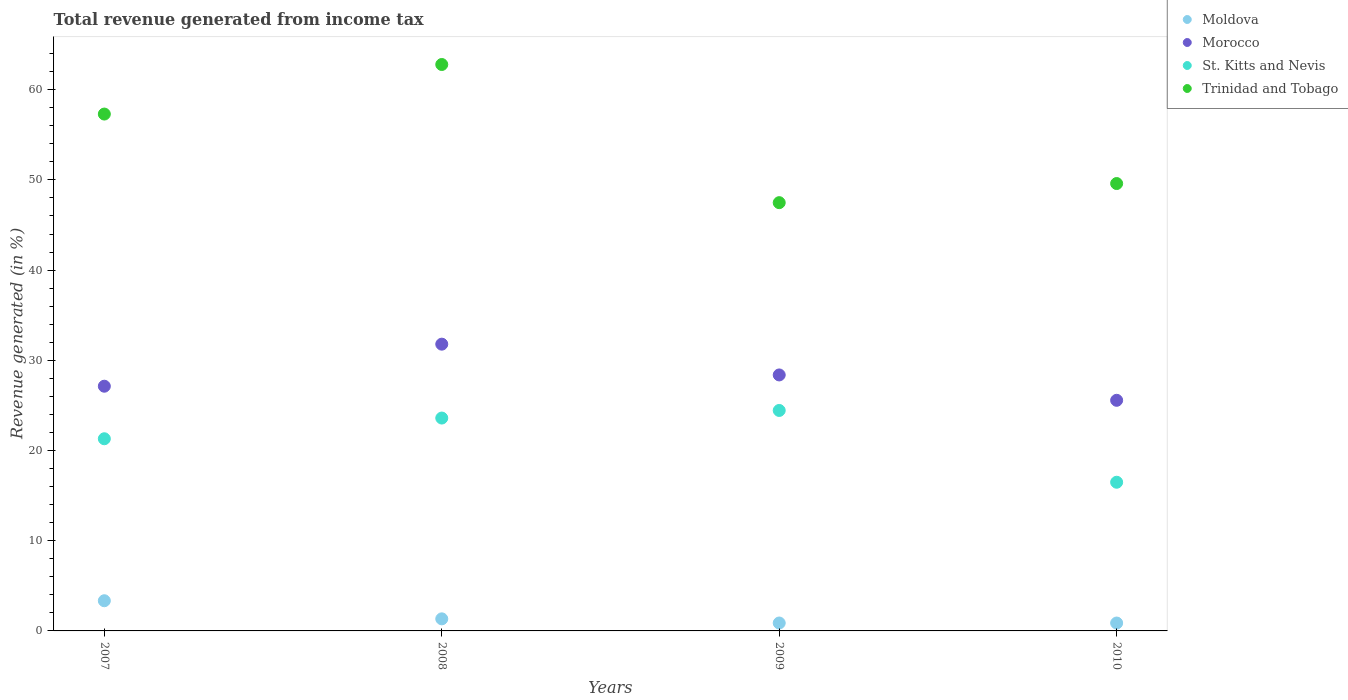How many different coloured dotlines are there?
Keep it short and to the point. 4. Is the number of dotlines equal to the number of legend labels?
Give a very brief answer. Yes. What is the total revenue generated in Moldova in 2007?
Provide a succinct answer. 3.35. Across all years, what is the maximum total revenue generated in St. Kitts and Nevis?
Offer a very short reply. 24.44. Across all years, what is the minimum total revenue generated in St. Kitts and Nevis?
Provide a succinct answer. 16.48. In which year was the total revenue generated in St. Kitts and Nevis minimum?
Your answer should be compact. 2010. What is the total total revenue generated in St. Kitts and Nevis in the graph?
Your answer should be very brief. 85.83. What is the difference between the total revenue generated in St. Kitts and Nevis in 2007 and that in 2008?
Ensure brevity in your answer.  -2.3. What is the difference between the total revenue generated in Trinidad and Tobago in 2009 and the total revenue generated in Moldova in 2008?
Give a very brief answer. 46.14. What is the average total revenue generated in St. Kitts and Nevis per year?
Provide a succinct answer. 21.46. In the year 2010, what is the difference between the total revenue generated in Trinidad and Tobago and total revenue generated in Morocco?
Your response must be concise. 24.03. In how many years, is the total revenue generated in Moldova greater than 32 %?
Ensure brevity in your answer.  0. What is the ratio of the total revenue generated in Moldova in 2007 to that in 2010?
Provide a short and direct response. 3.83. What is the difference between the highest and the second highest total revenue generated in Morocco?
Offer a very short reply. 3.41. What is the difference between the highest and the lowest total revenue generated in Moldova?
Offer a very short reply. 2.47. In how many years, is the total revenue generated in St. Kitts and Nevis greater than the average total revenue generated in St. Kitts and Nevis taken over all years?
Provide a short and direct response. 2. Is the sum of the total revenue generated in Moldova in 2007 and 2009 greater than the maximum total revenue generated in Morocco across all years?
Give a very brief answer. No. Is it the case that in every year, the sum of the total revenue generated in Trinidad and Tobago and total revenue generated in Moldova  is greater than the sum of total revenue generated in St. Kitts and Nevis and total revenue generated in Morocco?
Ensure brevity in your answer.  No. Is it the case that in every year, the sum of the total revenue generated in Trinidad and Tobago and total revenue generated in St. Kitts and Nevis  is greater than the total revenue generated in Moldova?
Your response must be concise. Yes. Does the total revenue generated in Moldova monotonically increase over the years?
Provide a short and direct response. No. Is the total revenue generated in Trinidad and Tobago strictly greater than the total revenue generated in St. Kitts and Nevis over the years?
Ensure brevity in your answer.  Yes. How many dotlines are there?
Your answer should be compact. 4. Are the values on the major ticks of Y-axis written in scientific E-notation?
Provide a succinct answer. No. Does the graph contain any zero values?
Offer a terse response. No. Where does the legend appear in the graph?
Provide a short and direct response. Top right. How are the legend labels stacked?
Give a very brief answer. Vertical. What is the title of the graph?
Ensure brevity in your answer.  Total revenue generated from income tax. What is the label or title of the X-axis?
Keep it short and to the point. Years. What is the label or title of the Y-axis?
Provide a succinct answer. Revenue generated (in %). What is the Revenue generated (in %) of Moldova in 2007?
Your answer should be very brief. 3.35. What is the Revenue generated (in %) of Morocco in 2007?
Offer a very short reply. 27.13. What is the Revenue generated (in %) in St. Kitts and Nevis in 2007?
Keep it short and to the point. 21.3. What is the Revenue generated (in %) of Trinidad and Tobago in 2007?
Provide a succinct answer. 57.3. What is the Revenue generated (in %) of Moldova in 2008?
Your answer should be compact. 1.34. What is the Revenue generated (in %) of Morocco in 2008?
Give a very brief answer. 31.79. What is the Revenue generated (in %) in St. Kitts and Nevis in 2008?
Provide a succinct answer. 23.6. What is the Revenue generated (in %) of Trinidad and Tobago in 2008?
Provide a short and direct response. 62.79. What is the Revenue generated (in %) of Moldova in 2009?
Give a very brief answer. 0.88. What is the Revenue generated (in %) of Morocco in 2009?
Offer a very short reply. 28.38. What is the Revenue generated (in %) of St. Kitts and Nevis in 2009?
Ensure brevity in your answer.  24.44. What is the Revenue generated (in %) in Trinidad and Tobago in 2009?
Make the answer very short. 47.48. What is the Revenue generated (in %) of Moldova in 2010?
Your answer should be very brief. 0.87. What is the Revenue generated (in %) in Morocco in 2010?
Offer a very short reply. 25.57. What is the Revenue generated (in %) of St. Kitts and Nevis in 2010?
Provide a succinct answer. 16.48. What is the Revenue generated (in %) of Trinidad and Tobago in 2010?
Your answer should be very brief. 49.6. Across all years, what is the maximum Revenue generated (in %) of Moldova?
Give a very brief answer. 3.35. Across all years, what is the maximum Revenue generated (in %) of Morocco?
Ensure brevity in your answer.  31.79. Across all years, what is the maximum Revenue generated (in %) in St. Kitts and Nevis?
Ensure brevity in your answer.  24.44. Across all years, what is the maximum Revenue generated (in %) of Trinidad and Tobago?
Make the answer very short. 62.79. Across all years, what is the minimum Revenue generated (in %) in Moldova?
Your response must be concise. 0.87. Across all years, what is the minimum Revenue generated (in %) in Morocco?
Provide a short and direct response. 25.57. Across all years, what is the minimum Revenue generated (in %) in St. Kitts and Nevis?
Provide a short and direct response. 16.48. Across all years, what is the minimum Revenue generated (in %) of Trinidad and Tobago?
Provide a succinct answer. 47.48. What is the total Revenue generated (in %) of Moldova in the graph?
Your answer should be compact. 6.44. What is the total Revenue generated (in %) in Morocco in the graph?
Your response must be concise. 112.86. What is the total Revenue generated (in %) of St. Kitts and Nevis in the graph?
Your response must be concise. 85.83. What is the total Revenue generated (in %) in Trinidad and Tobago in the graph?
Your response must be concise. 217.17. What is the difference between the Revenue generated (in %) of Moldova in 2007 and that in 2008?
Keep it short and to the point. 2.01. What is the difference between the Revenue generated (in %) of Morocco in 2007 and that in 2008?
Offer a very short reply. -4.66. What is the difference between the Revenue generated (in %) of St. Kitts and Nevis in 2007 and that in 2008?
Your answer should be compact. -2.3. What is the difference between the Revenue generated (in %) of Trinidad and Tobago in 2007 and that in 2008?
Ensure brevity in your answer.  -5.49. What is the difference between the Revenue generated (in %) of Moldova in 2007 and that in 2009?
Offer a very short reply. 2.47. What is the difference between the Revenue generated (in %) of Morocco in 2007 and that in 2009?
Keep it short and to the point. -1.25. What is the difference between the Revenue generated (in %) in St. Kitts and Nevis in 2007 and that in 2009?
Offer a terse response. -3.14. What is the difference between the Revenue generated (in %) in Trinidad and Tobago in 2007 and that in 2009?
Your answer should be compact. 9.82. What is the difference between the Revenue generated (in %) in Moldova in 2007 and that in 2010?
Give a very brief answer. 2.47. What is the difference between the Revenue generated (in %) in Morocco in 2007 and that in 2010?
Keep it short and to the point. 1.56. What is the difference between the Revenue generated (in %) of St. Kitts and Nevis in 2007 and that in 2010?
Your answer should be very brief. 4.82. What is the difference between the Revenue generated (in %) of Trinidad and Tobago in 2007 and that in 2010?
Make the answer very short. 7.7. What is the difference between the Revenue generated (in %) in Moldova in 2008 and that in 2009?
Your response must be concise. 0.46. What is the difference between the Revenue generated (in %) in Morocco in 2008 and that in 2009?
Provide a succinct answer. 3.41. What is the difference between the Revenue generated (in %) of St. Kitts and Nevis in 2008 and that in 2009?
Provide a succinct answer. -0.84. What is the difference between the Revenue generated (in %) in Trinidad and Tobago in 2008 and that in 2009?
Give a very brief answer. 15.32. What is the difference between the Revenue generated (in %) in Moldova in 2008 and that in 2010?
Make the answer very short. 0.46. What is the difference between the Revenue generated (in %) in Morocco in 2008 and that in 2010?
Your answer should be very brief. 6.22. What is the difference between the Revenue generated (in %) of St. Kitts and Nevis in 2008 and that in 2010?
Your answer should be compact. 7.12. What is the difference between the Revenue generated (in %) of Trinidad and Tobago in 2008 and that in 2010?
Provide a short and direct response. 13.2. What is the difference between the Revenue generated (in %) in Moldova in 2009 and that in 2010?
Ensure brevity in your answer.  0. What is the difference between the Revenue generated (in %) of Morocco in 2009 and that in 2010?
Keep it short and to the point. 2.81. What is the difference between the Revenue generated (in %) in St. Kitts and Nevis in 2009 and that in 2010?
Provide a succinct answer. 7.96. What is the difference between the Revenue generated (in %) in Trinidad and Tobago in 2009 and that in 2010?
Give a very brief answer. -2.12. What is the difference between the Revenue generated (in %) in Moldova in 2007 and the Revenue generated (in %) in Morocco in 2008?
Give a very brief answer. -28.44. What is the difference between the Revenue generated (in %) in Moldova in 2007 and the Revenue generated (in %) in St. Kitts and Nevis in 2008?
Ensure brevity in your answer.  -20.25. What is the difference between the Revenue generated (in %) in Moldova in 2007 and the Revenue generated (in %) in Trinidad and Tobago in 2008?
Your answer should be very brief. -59.45. What is the difference between the Revenue generated (in %) in Morocco in 2007 and the Revenue generated (in %) in St. Kitts and Nevis in 2008?
Offer a terse response. 3.53. What is the difference between the Revenue generated (in %) of Morocco in 2007 and the Revenue generated (in %) of Trinidad and Tobago in 2008?
Your answer should be compact. -35.67. What is the difference between the Revenue generated (in %) of St. Kitts and Nevis in 2007 and the Revenue generated (in %) of Trinidad and Tobago in 2008?
Ensure brevity in your answer.  -41.49. What is the difference between the Revenue generated (in %) of Moldova in 2007 and the Revenue generated (in %) of Morocco in 2009?
Give a very brief answer. -25.03. What is the difference between the Revenue generated (in %) in Moldova in 2007 and the Revenue generated (in %) in St. Kitts and Nevis in 2009?
Offer a very short reply. -21.1. What is the difference between the Revenue generated (in %) in Moldova in 2007 and the Revenue generated (in %) in Trinidad and Tobago in 2009?
Ensure brevity in your answer.  -44.13. What is the difference between the Revenue generated (in %) in Morocco in 2007 and the Revenue generated (in %) in St. Kitts and Nevis in 2009?
Offer a very short reply. 2.69. What is the difference between the Revenue generated (in %) of Morocco in 2007 and the Revenue generated (in %) of Trinidad and Tobago in 2009?
Your response must be concise. -20.35. What is the difference between the Revenue generated (in %) of St. Kitts and Nevis in 2007 and the Revenue generated (in %) of Trinidad and Tobago in 2009?
Offer a terse response. -26.17. What is the difference between the Revenue generated (in %) in Moldova in 2007 and the Revenue generated (in %) in Morocco in 2010?
Your response must be concise. -22.22. What is the difference between the Revenue generated (in %) of Moldova in 2007 and the Revenue generated (in %) of St. Kitts and Nevis in 2010?
Your answer should be very brief. -13.14. What is the difference between the Revenue generated (in %) in Moldova in 2007 and the Revenue generated (in %) in Trinidad and Tobago in 2010?
Ensure brevity in your answer.  -46.25. What is the difference between the Revenue generated (in %) in Morocco in 2007 and the Revenue generated (in %) in St. Kitts and Nevis in 2010?
Keep it short and to the point. 10.65. What is the difference between the Revenue generated (in %) of Morocco in 2007 and the Revenue generated (in %) of Trinidad and Tobago in 2010?
Offer a very short reply. -22.47. What is the difference between the Revenue generated (in %) in St. Kitts and Nevis in 2007 and the Revenue generated (in %) in Trinidad and Tobago in 2010?
Offer a terse response. -28.29. What is the difference between the Revenue generated (in %) of Moldova in 2008 and the Revenue generated (in %) of Morocco in 2009?
Keep it short and to the point. -27.04. What is the difference between the Revenue generated (in %) of Moldova in 2008 and the Revenue generated (in %) of St. Kitts and Nevis in 2009?
Your answer should be compact. -23.1. What is the difference between the Revenue generated (in %) of Moldova in 2008 and the Revenue generated (in %) of Trinidad and Tobago in 2009?
Offer a very short reply. -46.14. What is the difference between the Revenue generated (in %) of Morocco in 2008 and the Revenue generated (in %) of St. Kitts and Nevis in 2009?
Your response must be concise. 7.35. What is the difference between the Revenue generated (in %) of Morocco in 2008 and the Revenue generated (in %) of Trinidad and Tobago in 2009?
Give a very brief answer. -15.69. What is the difference between the Revenue generated (in %) of St. Kitts and Nevis in 2008 and the Revenue generated (in %) of Trinidad and Tobago in 2009?
Keep it short and to the point. -23.88. What is the difference between the Revenue generated (in %) of Moldova in 2008 and the Revenue generated (in %) of Morocco in 2010?
Provide a succinct answer. -24.23. What is the difference between the Revenue generated (in %) of Moldova in 2008 and the Revenue generated (in %) of St. Kitts and Nevis in 2010?
Make the answer very short. -15.14. What is the difference between the Revenue generated (in %) in Moldova in 2008 and the Revenue generated (in %) in Trinidad and Tobago in 2010?
Your answer should be very brief. -48.26. What is the difference between the Revenue generated (in %) in Morocco in 2008 and the Revenue generated (in %) in St. Kitts and Nevis in 2010?
Give a very brief answer. 15.31. What is the difference between the Revenue generated (in %) of Morocco in 2008 and the Revenue generated (in %) of Trinidad and Tobago in 2010?
Give a very brief answer. -17.81. What is the difference between the Revenue generated (in %) in St. Kitts and Nevis in 2008 and the Revenue generated (in %) in Trinidad and Tobago in 2010?
Your response must be concise. -26. What is the difference between the Revenue generated (in %) in Moldova in 2009 and the Revenue generated (in %) in Morocco in 2010?
Give a very brief answer. -24.69. What is the difference between the Revenue generated (in %) in Moldova in 2009 and the Revenue generated (in %) in St. Kitts and Nevis in 2010?
Ensure brevity in your answer.  -15.61. What is the difference between the Revenue generated (in %) in Moldova in 2009 and the Revenue generated (in %) in Trinidad and Tobago in 2010?
Give a very brief answer. -48.72. What is the difference between the Revenue generated (in %) of Morocco in 2009 and the Revenue generated (in %) of St. Kitts and Nevis in 2010?
Provide a succinct answer. 11.9. What is the difference between the Revenue generated (in %) in Morocco in 2009 and the Revenue generated (in %) in Trinidad and Tobago in 2010?
Your response must be concise. -21.22. What is the difference between the Revenue generated (in %) of St. Kitts and Nevis in 2009 and the Revenue generated (in %) of Trinidad and Tobago in 2010?
Give a very brief answer. -25.16. What is the average Revenue generated (in %) of Moldova per year?
Make the answer very short. 1.61. What is the average Revenue generated (in %) of Morocco per year?
Provide a short and direct response. 28.22. What is the average Revenue generated (in %) in St. Kitts and Nevis per year?
Make the answer very short. 21.46. What is the average Revenue generated (in %) in Trinidad and Tobago per year?
Give a very brief answer. 54.29. In the year 2007, what is the difference between the Revenue generated (in %) of Moldova and Revenue generated (in %) of Morocco?
Offer a terse response. -23.78. In the year 2007, what is the difference between the Revenue generated (in %) of Moldova and Revenue generated (in %) of St. Kitts and Nevis?
Provide a succinct answer. -17.96. In the year 2007, what is the difference between the Revenue generated (in %) of Moldova and Revenue generated (in %) of Trinidad and Tobago?
Offer a terse response. -53.95. In the year 2007, what is the difference between the Revenue generated (in %) in Morocco and Revenue generated (in %) in St. Kitts and Nevis?
Provide a short and direct response. 5.82. In the year 2007, what is the difference between the Revenue generated (in %) of Morocco and Revenue generated (in %) of Trinidad and Tobago?
Your answer should be compact. -30.17. In the year 2007, what is the difference between the Revenue generated (in %) in St. Kitts and Nevis and Revenue generated (in %) in Trinidad and Tobago?
Make the answer very short. -36. In the year 2008, what is the difference between the Revenue generated (in %) of Moldova and Revenue generated (in %) of Morocco?
Keep it short and to the point. -30.45. In the year 2008, what is the difference between the Revenue generated (in %) of Moldova and Revenue generated (in %) of St. Kitts and Nevis?
Provide a succinct answer. -22.26. In the year 2008, what is the difference between the Revenue generated (in %) in Moldova and Revenue generated (in %) in Trinidad and Tobago?
Offer a very short reply. -61.46. In the year 2008, what is the difference between the Revenue generated (in %) in Morocco and Revenue generated (in %) in St. Kitts and Nevis?
Make the answer very short. 8.19. In the year 2008, what is the difference between the Revenue generated (in %) in Morocco and Revenue generated (in %) in Trinidad and Tobago?
Your answer should be very brief. -31. In the year 2008, what is the difference between the Revenue generated (in %) in St. Kitts and Nevis and Revenue generated (in %) in Trinidad and Tobago?
Your answer should be very brief. -39.19. In the year 2009, what is the difference between the Revenue generated (in %) of Moldova and Revenue generated (in %) of Morocco?
Your response must be concise. -27.5. In the year 2009, what is the difference between the Revenue generated (in %) of Moldova and Revenue generated (in %) of St. Kitts and Nevis?
Provide a succinct answer. -23.56. In the year 2009, what is the difference between the Revenue generated (in %) of Moldova and Revenue generated (in %) of Trinidad and Tobago?
Keep it short and to the point. -46.6. In the year 2009, what is the difference between the Revenue generated (in %) in Morocco and Revenue generated (in %) in St. Kitts and Nevis?
Offer a terse response. 3.94. In the year 2009, what is the difference between the Revenue generated (in %) in Morocco and Revenue generated (in %) in Trinidad and Tobago?
Keep it short and to the point. -19.1. In the year 2009, what is the difference between the Revenue generated (in %) in St. Kitts and Nevis and Revenue generated (in %) in Trinidad and Tobago?
Keep it short and to the point. -23.04. In the year 2010, what is the difference between the Revenue generated (in %) of Moldova and Revenue generated (in %) of Morocco?
Your answer should be compact. -24.69. In the year 2010, what is the difference between the Revenue generated (in %) in Moldova and Revenue generated (in %) in St. Kitts and Nevis?
Your answer should be compact. -15.61. In the year 2010, what is the difference between the Revenue generated (in %) of Moldova and Revenue generated (in %) of Trinidad and Tobago?
Offer a very short reply. -48.72. In the year 2010, what is the difference between the Revenue generated (in %) of Morocco and Revenue generated (in %) of St. Kitts and Nevis?
Offer a terse response. 9.08. In the year 2010, what is the difference between the Revenue generated (in %) of Morocco and Revenue generated (in %) of Trinidad and Tobago?
Provide a succinct answer. -24.03. In the year 2010, what is the difference between the Revenue generated (in %) of St. Kitts and Nevis and Revenue generated (in %) of Trinidad and Tobago?
Provide a short and direct response. -33.11. What is the ratio of the Revenue generated (in %) in Moldova in 2007 to that in 2008?
Offer a very short reply. 2.5. What is the ratio of the Revenue generated (in %) in Morocco in 2007 to that in 2008?
Keep it short and to the point. 0.85. What is the ratio of the Revenue generated (in %) in St. Kitts and Nevis in 2007 to that in 2008?
Ensure brevity in your answer.  0.9. What is the ratio of the Revenue generated (in %) of Trinidad and Tobago in 2007 to that in 2008?
Give a very brief answer. 0.91. What is the ratio of the Revenue generated (in %) in Moldova in 2007 to that in 2009?
Give a very brief answer. 3.81. What is the ratio of the Revenue generated (in %) of Morocco in 2007 to that in 2009?
Provide a succinct answer. 0.96. What is the ratio of the Revenue generated (in %) in St. Kitts and Nevis in 2007 to that in 2009?
Your answer should be very brief. 0.87. What is the ratio of the Revenue generated (in %) in Trinidad and Tobago in 2007 to that in 2009?
Ensure brevity in your answer.  1.21. What is the ratio of the Revenue generated (in %) in Moldova in 2007 to that in 2010?
Your answer should be very brief. 3.83. What is the ratio of the Revenue generated (in %) in Morocco in 2007 to that in 2010?
Give a very brief answer. 1.06. What is the ratio of the Revenue generated (in %) of St. Kitts and Nevis in 2007 to that in 2010?
Ensure brevity in your answer.  1.29. What is the ratio of the Revenue generated (in %) in Trinidad and Tobago in 2007 to that in 2010?
Provide a succinct answer. 1.16. What is the ratio of the Revenue generated (in %) in Moldova in 2008 to that in 2009?
Make the answer very short. 1.53. What is the ratio of the Revenue generated (in %) of Morocco in 2008 to that in 2009?
Your answer should be compact. 1.12. What is the ratio of the Revenue generated (in %) of St. Kitts and Nevis in 2008 to that in 2009?
Provide a short and direct response. 0.97. What is the ratio of the Revenue generated (in %) in Trinidad and Tobago in 2008 to that in 2009?
Your answer should be compact. 1.32. What is the ratio of the Revenue generated (in %) in Moldova in 2008 to that in 2010?
Offer a terse response. 1.53. What is the ratio of the Revenue generated (in %) of Morocco in 2008 to that in 2010?
Your response must be concise. 1.24. What is the ratio of the Revenue generated (in %) in St. Kitts and Nevis in 2008 to that in 2010?
Offer a terse response. 1.43. What is the ratio of the Revenue generated (in %) in Trinidad and Tobago in 2008 to that in 2010?
Provide a succinct answer. 1.27. What is the ratio of the Revenue generated (in %) of Moldova in 2009 to that in 2010?
Make the answer very short. 1. What is the ratio of the Revenue generated (in %) in Morocco in 2009 to that in 2010?
Your response must be concise. 1.11. What is the ratio of the Revenue generated (in %) of St. Kitts and Nevis in 2009 to that in 2010?
Give a very brief answer. 1.48. What is the ratio of the Revenue generated (in %) in Trinidad and Tobago in 2009 to that in 2010?
Give a very brief answer. 0.96. What is the difference between the highest and the second highest Revenue generated (in %) in Moldova?
Provide a succinct answer. 2.01. What is the difference between the highest and the second highest Revenue generated (in %) of Morocco?
Offer a terse response. 3.41. What is the difference between the highest and the second highest Revenue generated (in %) in St. Kitts and Nevis?
Make the answer very short. 0.84. What is the difference between the highest and the second highest Revenue generated (in %) in Trinidad and Tobago?
Ensure brevity in your answer.  5.49. What is the difference between the highest and the lowest Revenue generated (in %) of Moldova?
Your response must be concise. 2.47. What is the difference between the highest and the lowest Revenue generated (in %) in Morocco?
Provide a succinct answer. 6.22. What is the difference between the highest and the lowest Revenue generated (in %) in St. Kitts and Nevis?
Your response must be concise. 7.96. What is the difference between the highest and the lowest Revenue generated (in %) of Trinidad and Tobago?
Provide a succinct answer. 15.32. 